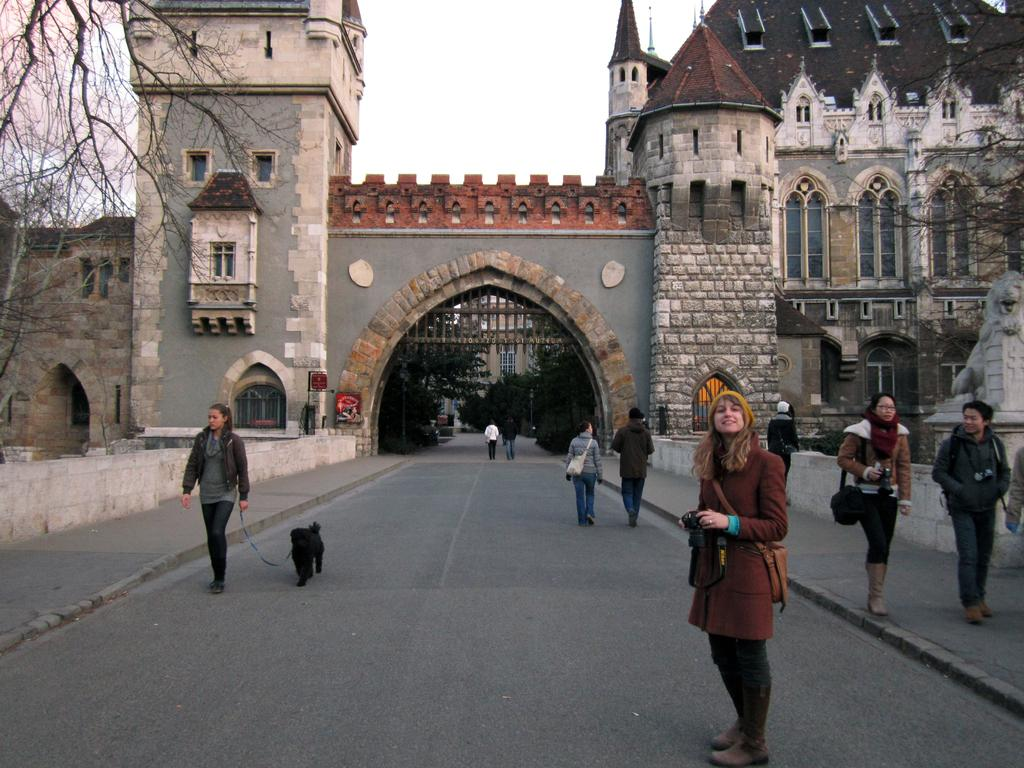What are the people in the image doing? The people in the image are standing and walking on the road. What can be seen in the background of the image? There is a castle in the background. What is visible in the sky in the image? The sky is visible in the image. What type of vegetation is present on either side of the road? There are trees on either side of the road. Where are the mice hiding in the image? There are no mice present in the image. What type of pump is visible in the image? There is no pump present in the image. 